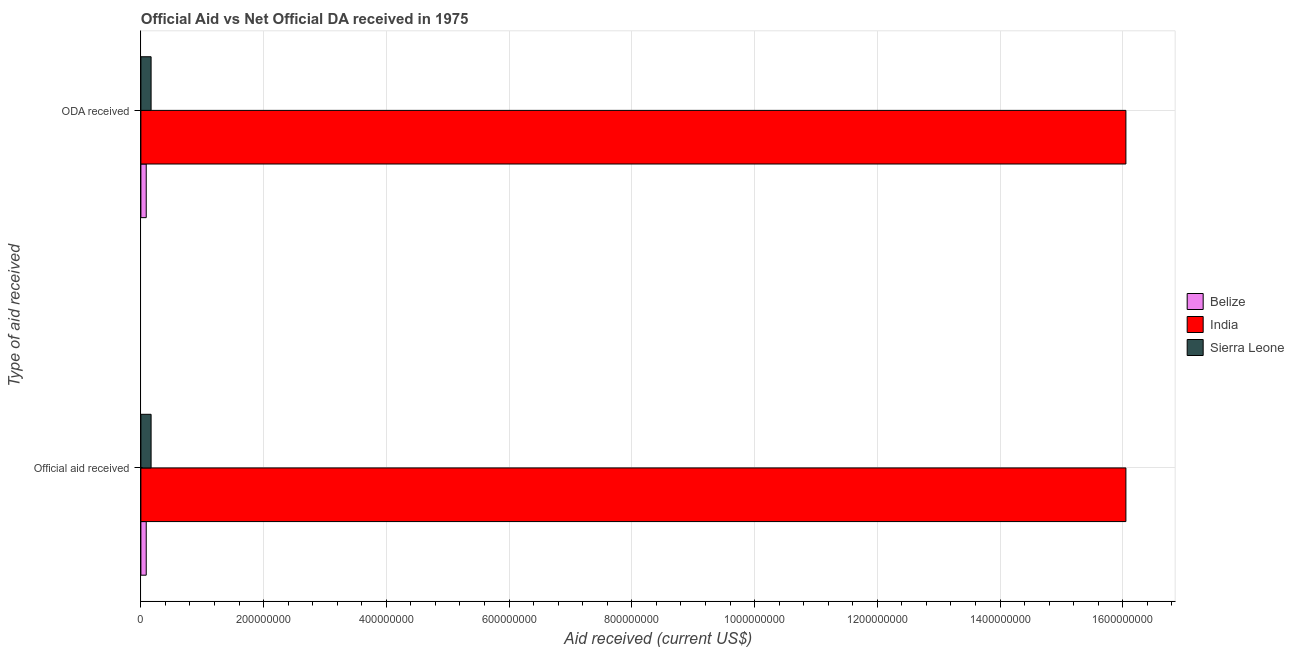How many groups of bars are there?
Your answer should be very brief. 2. Are the number of bars per tick equal to the number of legend labels?
Offer a terse response. Yes. How many bars are there on the 1st tick from the bottom?
Offer a very short reply. 3. What is the label of the 1st group of bars from the top?
Your response must be concise. ODA received. What is the official aid received in Belize?
Your answer should be compact. 8.71e+06. Across all countries, what is the maximum oda received?
Offer a terse response. 1.61e+09. Across all countries, what is the minimum official aid received?
Provide a short and direct response. 8.71e+06. In which country was the official aid received maximum?
Your response must be concise. India. In which country was the official aid received minimum?
Offer a terse response. Belize. What is the total official aid received in the graph?
Ensure brevity in your answer.  1.63e+09. What is the difference between the official aid received in India and that in Sierra Leone?
Give a very brief answer. 1.59e+09. What is the difference between the official aid received in India and the oda received in Sierra Leone?
Your answer should be compact. 1.59e+09. What is the average oda received per country?
Your response must be concise. 5.44e+08. What is the ratio of the oda received in Belize to that in India?
Keep it short and to the point. 0.01. Is the oda received in Belize less than that in Sierra Leone?
Ensure brevity in your answer.  Yes. What does the 3rd bar from the top in ODA received represents?
Keep it short and to the point. Belize. What does the 3rd bar from the bottom in Official aid received represents?
Provide a succinct answer. Sierra Leone. Are all the bars in the graph horizontal?
Provide a succinct answer. Yes. What is the difference between two consecutive major ticks on the X-axis?
Offer a very short reply. 2.00e+08. Are the values on the major ticks of X-axis written in scientific E-notation?
Give a very brief answer. No. Does the graph contain any zero values?
Your response must be concise. No. Does the graph contain grids?
Provide a short and direct response. Yes. Where does the legend appear in the graph?
Offer a terse response. Center right. How many legend labels are there?
Keep it short and to the point. 3. What is the title of the graph?
Keep it short and to the point. Official Aid vs Net Official DA received in 1975 . What is the label or title of the X-axis?
Keep it short and to the point. Aid received (current US$). What is the label or title of the Y-axis?
Your response must be concise. Type of aid received. What is the Aid received (current US$) of Belize in Official aid received?
Keep it short and to the point. 8.71e+06. What is the Aid received (current US$) of India in Official aid received?
Ensure brevity in your answer.  1.61e+09. What is the Aid received (current US$) of Sierra Leone in Official aid received?
Ensure brevity in your answer.  1.66e+07. What is the Aid received (current US$) of Belize in ODA received?
Make the answer very short. 8.71e+06. What is the Aid received (current US$) in India in ODA received?
Your answer should be very brief. 1.61e+09. What is the Aid received (current US$) of Sierra Leone in ODA received?
Your response must be concise. 1.66e+07. Across all Type of aid received, what is the maximum Aid received (current US$) of Belize?
Your response must be concise. 8.71e+06. Across all Type of aid received, what is the maximum Aid received (current US$) in India?
Offer a terse response. 1.61e+09. Across all Type of aid received, what is the maximum Aid received (current US$) in Sierra Leone?
Provide a succinct answer. 1.66e+07. Across all Type of aid received, what is the minimum Aid received (current US$) of Belize?
Ensure brevity in your answer.  8.71e+06. Across all Type of aid received, what is the minimum Aid received (current US$) of India?
Your response must be concise. 1.61e+09. Across all Type of aid received, what is the minimum Aid received (current US$) of Sierra Leone?
Keep it short and to the point. 1.66e+07. What is the total Aid received (current US$) of Belize in the graph?
Offer a terse response. 1.74e+07. What is the total Aid received (current US$) in India in the graph?
Provide a succinct answer. 3.21e+09. What is the total Aid received (current US$) in Sierra Leone in the graph?
Offer a terse response. 3.33e+07. What is the difference between the Aid received (current US$) of Belize in Official aid received and that in ODA received?
Offer a very short reply. 0. What is the difference between the Aid received (current US$) of Belize in Official aid received and the Aid received (current US$) of India in ODA received?
Offer a terse response. -1.60e+09. What is the difference between the Aid received (current US$) of Belize in Official aid received and the Aid received (current US$) of Sierra Leone in ODA received?
Give a very brief answer. -7.92e+06. What is the difference between the Aid received (current US$) of India in Official aid received and the Aid received (current US$) of Sierra Leone in ODA received?
Offer a very short reply. 1.59e+09. What is the average Aid received (current US$) of Belize per Type of aid received?
Your response must be concise. 8.71e+06. What is the average Aid received (current US$) of India per Type of aid received?
Ensure brevity in your answer.  1.61e+09. What is the average Aid received (current US$) in Sierra Leone per Type of aid received?
Your answer should be very brief. 1.66e+07. What is the difference between the Aid received (current US$) of Belize and Aid received (current US$) of India in Official aid received?
Provide a succinct answer. -1.60e+09. What is the difference between the Aid received (current US$) of Belize and Aid received (current US$) of Sierra Leone in Official aid received?
Keep it short and to the point. -7.92e+06. What is the difference between the Aid received (current US$) of India and Aid received (current US$) of Sierra Leone in Official aid received?
Make the answer very short. 1.59e+09. What is the difference between the Aid received (current US$) in Belize and Aid received (current US$) in India in ODA received?
Your response must be concise. -1.60e+09. What is the difference between the Aid received (current US$) in Belize and Aid received (current US$) in Sierra Leone in ODA received?
Your answer should be compact. -7.92e+06. What is the difference between the Aid received (current US$) in India and Aid received (current US$) in Sierra Leone in ODA received?
Keep it short and to the point. 1.59e+09. What is the ratio of the Aid received (current US$) of India in Official aid received to that in ODA received?
Your answer should be compact. 1. What is the ratio of the Aid received (current US$) in Sierra Leone in Official aid received to that in ODA received?
Make the answer very short. 1. What is the difference between the highest and the second highest Aid received (current US$) of India?
Your answer should be compact. 0. What is the difference between the highest and the second highest Aid received (current US$) in Sierra Leone?
Your answer should be very brief. 0. What is the difference between the highest and the lowest Aid received (current US$) of Belize?
Your response must be concise. 0. What is the difference between the highest and the lowest Aid received (current US$) in India?
Ensure brevity in your answer.  0. What is the difference between the highest and the lowest Aid received (current US$) in Sierra Leone?
Your answer should be very brief. 0. 